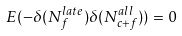<formula> <loc_0><loc_0><loc_500><loc_500>E ( - \delta ( N _ { f } ^ { l a t e } ) \delta ( N _ { c + f } ^ { a l l } ) ) = 0</formula> 